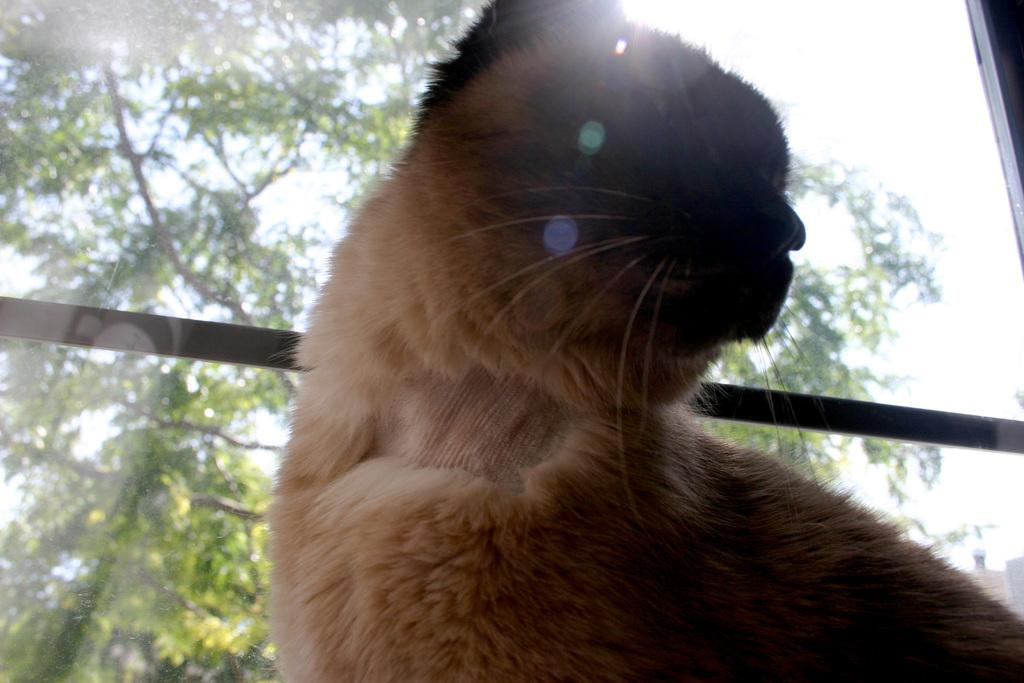What type of animal is in the image? There is a cat in the image. What is behind the cat in the image? There is a glass window behind the cat. What can be seen through the glass window? Trees and the sky are visible through the glass window. How many ears does the cat have in the image? The number of ears cannot be determined from the image, but cats typically have two ears. What scientific experiment is being conducted in the image? There is no scientific experiment visible in the image. 